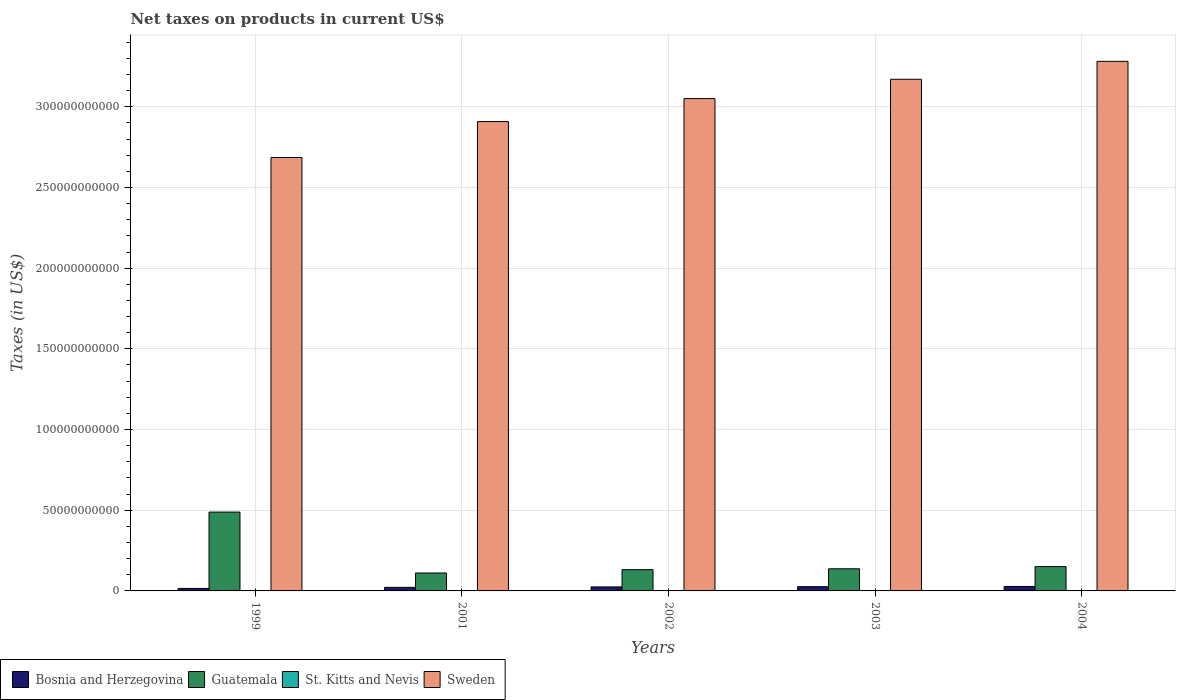How many groups of bars are there?
Your response must be concise. 5. What is the net taxes on products in Sweden in 2002?
Give a very brief answer. 3.05e+11. Across all years, what is the maximum net taxes on products in Guatemala?
Your answer should be compact. 4.89e+1. Across all years, what is the minimum net taxes on products in Bosnia and Herzegovina?
Make the answer very short. 1.54e+09. In which year was the net taxes on products in Sweden maximum?
Your answer should be very brief. 2004. In which year was the net taxes on products in St. Kitts and Nevis minimum?
Your answer should be compact. 2001. What is the total net taxes on products in Sweden in the graph?
Make the answer very short. 1.51e+12. What is the difference between the net taxes on products in Bosnia and Herzegovina in 2001 and that in 2002?
Make the answer very short. -2.75e+08. What is the difference between the net taxes on products in Bosnia and Herzegovina in 2001 and the net taxes on products in Sweden in 1999?
Make the answer very short. -2.66e+11. What is the average net taxes on products in Bosnia and Herzegovina per year?
Make the answer very short. 2.33e+09. In the year 2001, what is the difference between the net taxes on products in St. Kitts and Nevis and net taxes on products in Guatemala?
Give a very brief answer. -1.10e+1. In how many years, is the net taxes on products in Sweden greater than 260000000000 US$?
Offer a terse response. 5. What is the ratio of the net taxes on products in St. Kitts and Nevis in 2003 to that in 2004?
Keep it short and to the point. 0.88. What is the difference between the highest and the second highest net taxes on products in Guatemala?
Provide a succinct answer. 3.38e+1. What is the difference between the highest and the lowest net taxes on products in Sweden?
Offer a terse response. 5.96e+1. In how many years, is the net taxes on products in Sweden greater than the average net taxes on products in Sweden taken over all years?
Make the answer very short. 3. Is the sum of the net taxes on products in Bosnia and Herzegovina in 1999 and 2002 greater than the maximum net taxes on products in St. Kitts and Nevis across all years?
Your response must be concise. Yes. What does the 3rd bar from the left in 2001 represents?
Provide a short and direct response. St. Kitts and Nevis. How many bars are there?
Give a very brief answer. 20. Are all the bars in the graph horizontal?
Your answer should be very brief. No. How many years are there in the graph?
Offer a very short reply. 5. What is the difference between two consecutive major ticks on the Y-axis?
Keep it short and to the point. 5.00e+1. Does the graph contain any zero values?
Offer a terse response. No. Where does the legend appear in the graph?
Provide a short and direct response. Bottom left. How many legend labels are there?
Keep it short and to the point. 4. How are the legend labels stacked?
Ensure brevity in your answer.  Horizontal. What is the title of the graph?
Your response must be concise. Net taxes on products in current US$. Does "Norway" appear as one of the legend labels in the graph?
Provide a succinct answer. No. What is the label or title of the X-axis?
Ensure brevity in your answer.  Years. What is the label or title of the Y-axis?
Keep it short and to the point. Taxes (in US$). What is the Taxes (in US$) in Bosnia and Herzegovina in 1999?
Offer a terse response. 1.54e+09. What is the Taxes (in US$) of Guatemala in 1999?
Your answer should be compact. 4.89e+1. What is the Taxes (in US$) in St. Kitts and Nevis in 1999?
Your answer should be compact. 1.29e+08. What is the Taxes (in US$) in Sweden in 1999?
Your answer should be compact. 2.69e+11. What is the Taxes (in US$) of Bosnia and Herzegovina in 2001?
Offer a very short reply. 2.21e+09. What is the Taxes (in US$) in Guatemala in 2001?
Your response must be concise. 1.11e+1. What is the Taxes (in US$) of St. Kitts and Nevis in 2001?
Give a very brief answer. 1.27e+08. What is the Taxes (in US$) of Sweden in 2001?
Your response must be concise. 2.91e+11. What is the Taxes (in US$) of Bosnia and Herzegovina in 2002?
Make the answer very short. 2.49e+09. What is the Taxes (in US$) in Guatemala in 2002?
Your answer should be very brief. 1.32e+1. What is the Taxes (in US$) in St. Kitts and Nevis in 2002?
Provide a short and direct response. 1.40e+08. What is the Taxes (in US$) of Sweden in 2002?
Your answer should be compact. 3.05e+11. What is the Taxes (in US$) in Bosnia and Herzegovina in 2003?
Ensure brevity in your answer.  2.63e+09. What is the Taxes (in US$) in Guatemala in 2003?
Offer a terse response. 1.37e+1. What is the Taxes (in US$) in St. Kitts and Nevis in 2003?
Keep it short and to the point. 1.56e+08. What is the Taxes (in US$) in Sweden in 2003?
Make the answer very short. 3.17e+11. What is the Taxes (in US$) of Bosnia and Herzegovina in 2004?
Make the answer very short. 2.77e+09. What is the Taxes (in US$) of Guatemala in 2004?
Provide a short and direct response. 1.51e+1. What is the Taxes (in US$) in St. Kitts and Nevis in 2004?
Keep it short and to the point. 1.77e+08. What is the Taxes (in US$) of Sweden in 2004?
Give a very brief answer. 3.28e+11. Across all years, what is the maximum Taxes (in US$) in Bosnia and Herzegovina?
Your answer should be very brief. 2.77e+09. Across all years, what is the maximum Taxes (in US$) of Guatemala?
Your answer should be very brief. 4.89e+1. Across all years, what is the maximum Taxes (in US$) in St. Kitts and Nevis?
Your answer should be compact. 1.77e+08. Across all years, what is the maximum Taxes (in US$) in Sweden?
Your answer should be very brief. 3.28e+11. Across all years, what is the minimum Taxes (in US$) in Bosnia and Herzegovina?
Offer a terse response. 1.54e+09. Across all years, what is the minimum Taxes (in US$) of Guatemala?
Your response must be concise. 1.11e+1. Across all years, what is the minimum Taxes (in US$) in St. Kitts and Nevis?
Offer a very short reply. 1.27e+08. Across all years, what is the minimum Taxes (in US$) in Sweden?
Your response must be concise. 2.69e+11. What is the total Taxes (in US$) of Bosnia and Herzegovina in the graph?
Your answer should be very brief. 1.16e+1. What is the total Taxes (in US$) in Guatemala in the graph?
Provide a succinct answer. 1.02e+11. What is the total Taxes (in US$) of St. Kitts and Nevis in the graph?
Give a very brief answer. 7.28e+08. What is the total Taxes (in US$) of Sweden in the graph?
Your answer should be very brief. 1.51e+12. What is the difference between the Taxes (in US$) in Bosnia and Herzegovina in 1999 and that in 2001?
Your response must be concise. -6.72e+08. What is the difference between the Taxes (in US$) in Guatemala in 1999 and that in 2001?
Give a very brief answer. 3.77e+1. What is the difference between the Taxes (in US$) of St. Kitts and Nevis in 1999 and that in 2001?
Make the answer very short. 2.08e+06. What is the difference between the Taxes (in US$) in Sweden in 1999 and that in 2001?
Ensure brevity in your answer.  -2.22e+1. What is the difference between the Taxes (in US$) in Bosnia and Herzegovina in 1999 and that in 2002?
Provide a succinct answer. -9.47e+08. What is the difference between the Taxes (in US$) in Guatemala in 1999 and that in 2002?
Ensure brevity in your answer.  3.57e+1. What is the difference between the Taxes (in US$) of St. Kitts and Nevis in 1999 and that in 2002?
Your answer should be very brief. -1.12e+07. What is the difference between the Taxes (in US$) in Sweden in 1999 and that in 2002?
Your response must be concise. -3.65e+1. What is the difference between the Taxes (in US$) in Bosnia and Herzegovina in 1999 and that in 2003?
Keep it short and to the point. -1.09e+09. What is the difference between the Taxes (in US$) of Guatemala in 1999 and that in 2003?
Provide a succinct answer. 3.51e+1. What is the difference between the Taxes (in US$) of St. Kitts and Nevis in 1999 and that in 2003?
Keep it short and to the point. -2.71e+07. What is the difference between the Taxes (in US$) in Sweden in 1999 and that in 2003?
Your answer should be very brief. -4.85e+1. What is the difference between the Taxes (in US$) in Bosnia and Herzegovina in 1999 and that in 2004?
Offer a very short reply. -1.23e+09. What is the difference between the Taxes (in US$) of Guatemala in 1999 and that in 2004?
Make the answer very short. 3.38e+1. What is the difference between the Taxes (in US$) of St. Kitts and Nevis in 1999 and that in 2004?
Your answer should be very brief. -4.76e+07. What is the difference between the Taxes (in US$) in Sweden in 1999 and that in 2004?
Keep it short and to the point. -5.96e+1. What is the difference between the Taxes (in US$) of Bosnia and Herzegovina in 2001 and that in 2002?
Offer a very short reply. -2.75e+08. What is the difference between the Taxes (in US$) in Guatemala in 2001 and that in 2002?
Make the answer very short. -2.08e+09. What is the difference between the Taxes (in US$) in St. Kitts and Nevis in 2001 and that in 2002?
Offer a very short reply. -1.33e+07. What is the difference between the Taxes (in US$) of Sweden in 2001 and that in 2002?
Keep it short and to the point. -1.42e+1. What is the difference between the Taxes (in US$) in Bosnia and Herzegovina in 2001 and that in 2003?
Make the answer very short. -4.14e+08. What is the difference between the Taxes (in US$) of Guatemala in 2001 and that in 2003?
Give a very brief answer. -2.61e+09. What is the difference between the Taxes (in US$) of St. Kitts and Nevis in 2001 and that in 2003?
Keep it short and to the point. -2.92e+07. What is the difference between the Taxes (in US$) in Sweden in 2001 and that in 2003?
Offer a terse response. -2.62e+1. What is the difference between the Taxes (in US$) in Bosnia and Herzegovina in 2001 and that in 2004?
Your answer should be compact. -5.57e+08. What is the difference between the Taxes (in US$) in Guatemala in 2001 and that in 2004?
Provide a short and direct response. -3.95e+09. What is the difference between the Taxes (in US$) of St. Kitts and Nevis in 2001 and that in 2004?
Offer a very short reply. -4.97e+07. What is the difference between the Taxes (in US$) of Sweden in 2001 and that in 2004?
Make the answer very short. -3.73e+1. What is the difference between the Taxes (in US$) of Bosnia and Herzegovina in 2002 and that in 2003?
Give a very brief answer. -1.39e+08. What is the difference between the Taxes (in US$) of Guatemala in 2002 and that in 2003?
Keep it short and to the point. -5.32e+08. What is the difference between the Taxes (in US$) of St. Kitts and Nevis in 2002 and that in 2003?
Give a very brief answer. -1.59e+07. What is the difference between the Taxes (in US$) in Sweden in 2002 and that in 2003?
Provide a short and direct response. -1.20e+1. What is the difference between the Taxes (in US$) in Bosnia and Herzegovina in 2002 and that in 2004?
Offer a terse response. -2.81e+08. What is the difference between the Taxes (in US$) in Guatemala in 2002 and that in 2004?
Provide a succinct answer. -1.87e+09. What is the difference between the Taxes (in US$) in St. Kitts and Nevis in 2002 and that in 2004?
Keep it short and to the point. -3.64e+07. What is the difference between the Taxes (in US$) in Sweden in 2002 and that in 2004?
Your response must be concise. -2.31e+1. What is the difference between the Taxes (in US$) of Bosnia and Herzegovina in 2003 and that in 2004?
Give a very brief answer. -1.42e+08. What is the difference between the Taxes (in US$) of Guatemala in 2003 and that in 2004?
Make the answer very short. -1.34e+09. What is the difference between the Taxes (in US$) of St. Kitts and Nevis in 2003 and that in 2004?
Your response must be concise. -2.05e+07. What is the difference between the Taxes (in US$) in Sweden in 2003 and that in 2004?
Keep it short and to the point. -1.11e+1. What is the difference between the Taxes (in US$) in Bosnia and Herzegovina in 1999 and the Taxes (in US$) in Guatemala in 2001?
Ensure brevity in your answer.  -9.57e+09. What is the difference between the Taxes (in US$) in Bosnia and Herzegovina in 1999 and the Taxes (in US$) in St. Kitts and Nevis in 2001?
Ensure brevity in your answer.  1.41e+09. What is the difference between the Taxes (in US$) in Bosnia and Herzegovina in 1999 and the Taxes (in US$) in Sweden in 2001?
Your response must be concise. -2.89e+11. What is the difference between the Taxes (in US$) of Guatemala in 1999 and the Taxes (in US$) of St. Kitts and Nevis in 2001?
Make the answer very short. 4.87e+1. What is the difference between the Taxes (in US$) of Guatemala in 1999 and the Taxes (in US$) of Sweden in 2001?
Provide a short and direct response. -2.42e+11. What is the difference between the Taxes (in US$) of St. Kitts and Nevis in 1999 and the Taxes (in US$) of Sweden in 2001?
Provide a short and direct response. -2.91e+11. What is the difference between the Taxes (in US$) in Bosnia and Herzegovina in 1999 and the Taxes (in US$) in Guatemala in 2002?
Your response must be concise. -1.16e+1. What is the difference between the Taxes (in US$) in Bosnia and Herzegovina in 1999 and the Taxes (in US$) in St. Kitts and Nevis in 2002?
Offer a very short reply. 1.40e+09. What is the difference between the Taxes (in US$) in Bosnia and Herzegovina in 1999 and the Taxes (in US$) in Sweden in 2002?
Your answer should be compact. -3.04e+11. What is the difference between the Taxes (in US$) of Guatemala in 1999 and the Taxes (in US$) of St. Kitts and Nevis in 2002?
Offer a terse response. 4.87e+1. What is the difference between the Taxes (in US$) of Guatemala in 1999 and the Taxes (in US$) of Sweden in 2002?
Provide a succinct answer. -2.56e+11. What is the difference between the Taxes (in US$) in St. Kitts and Nevis in 1999 and the Taxes (in US$) in Sweden in 2002?
Your answer should be very brief. -3.05e+11. What is the difference between the Taxes (in US$) in Bosnia and Herzegovina in 1999 and the Taxes (in US$) in Guatemala in 2003?
Ensure brevity in your answer.  -1.22e+1. What is the difference between the Taxes (in US$) in Bosnia and Herzegovina in 1999 and the Taxes (in US$) in St. Kitts and Nevis in 2003?
Your response must be concise. 1.38e+09. What is the difference between the Taxes (in US$) of Bosnia and Herzegovina in 1999 and the Taxes (in US$) of Sweden in 2003?
Your answer should be compact. -3.16e+11. What is the difference between the Taxes (in US$) in Guatemala in 1999 and the Taxes (in US$) in St. Kitts and Nevis in 2003?
Give a very brief answer. 4.87e+1. What is the difference between the Taxes (in US$) of Guatemala in 1999 and the Taxes (in US$) of Sweden in 2003?
Your response must be concise. -2.68e+11. What is the difference between the Taxes (in US$) of St. Kitts and Nevis in 1999 and the Taxes (in US$) of Sweden in 2003?
Ensure brevity in your answer.  -3.17e+11. What is the difference between the Taxes (in US$) of Bosnia and Herzegovina in 1999 and the Taxes (in US$) of Guatemala in 2004?
Your answer should be very brief. -1.35e+1. What is the difference between the Taxes (in US$) of Bosnia and Herzegovina in 1999 and the Taxes (in US$) of St. Kitts and Nevis in 2004?
Your response must be concise. 1.36e+09. What is the difference between the Taxes (in US$) in Bosnia and Herzegovina in 1999 and the Taxes (in US$) in Sweden in 2004?
Your answer should be very brief. -3.27e+11. What is the difference between the Taxes (in US$) in Guatemala in 1999 and the Taxes (in US$) in St. Kitts and Nevis in 2004?
Provide a short and direct response. 4.87e+1. What is the difference between the Taxes (in US$) in Guatemala in 1999 and the Taxes (in US$) in Sweden in 2004?
Give a very brief answer. -2.79e+11. What is the difference between the Taxes (in US$) in St. Kitts and Nevis in 1999 and the Taxes (in US$) in Sweden in 2004?
Offer a very short reply. -3.28e+11. What is the difference between the Taxes (in US$) of Bosnia and Herzegovina in 2001 and the Taxes (in US$) of Guatemala in 2002?
Ensure brevity in your answer.  -1.10e+1. What is the difference between the Taxes (in US$) of Bosnia and Herzegovina in 2001 and the Taxes (in US$) of St. Kitts and Nevis in 2002?
Give a very brief answer. 2.07e+09. What is the difference between the Taxes (in US$) of Bosnia and Herzegovina in 2001 and the Taxes (in US$) of Sweden in 2002?
Make the answer very short. -3.03e+11. What is the difference between the Taxes (in US$) in Guatemala in 2001 and the Taxes (in US$) in St. Kitts and Nevis in 2002?
Your response must be concise. 1.10e+1. What is the difference between the Taxes (in US$) in Guatemala in 2001 and the Taxes (in US$) in Sweden in 2002?
Provide a short and direct response. -2.94e+11. What is the difference between the Taxes (in US$) of St. Kitts and Nevis in 2001 and the Taxes (in US$) of Sweden in 2002?
Offer a terse response. -3.05e+11. What is the difference between the Taxes (in US$) of Bosnia and Herzegovina in 2001 and the Taxes (in US$) of Guatemala in 2003?
Your answer should be compact. -1.15e+1. What is the difference between the Taxes (in US$) of Bosnia and Herzegovina in 2001 and the Taxes (in US$) of St. Kitts and Nevis in 2003?
Make the answer very short. 2.05e+09. What is the difference between the Taxes (in US$) in Bosnia and Herzegovina in 2001 and the Taxes (in US$) in Sweden in 2003?
Your answer should be very brief. -3.15e+11. What is the difference between the Taxes (in US$) in Guatemala in 2001 and the Taxes (in US$) in St. Kitts and Nevis in 2003?
Your response must be concise. 1.10e+1. What is the difference between the Taxes (in US$) in Guatemala in 2001 and the Taxes (in US$) in Sweden in 2003?
Offer a very short reply. -3.06e+11. What is the difference between the Taxes (in US$) in St. Kitts and Nevis in 2001 and the Taxes (in US$) in Sweden in 2003?
Offer a terse response. -3.17e+11. What is the difference between the Taxes (in US$) of Bosnia and Herzegovina in 2001 and the Taxes (in US$) of Guatemala in 2004?
Provide a succinct answer. -1.28e+1. What is the difference between the Taxes (in US$) in Bosnia and Herzegovina in 2001 and the Taxes (in US$) in St. Kitts and Nevis in 2004?
Your answer should be very brief. 2.03e+09. What is the difference between the Taxes (in US$) in Bosnia and Herzegovina in 2001 and the Taxes (in US$) in Sweden in 2004?
Your answer should be compact. -3.26e+11. What is the difference between the Taxes (in US$) in Guatemala in 2001 and the Taxes (in US$) in St. Kitts and Nevis in 2004?
Make the answer very short. 1.09e+1. What is the difference between the Taxes (in US$) in Guatemala in 2001 and the Taxes (in US$) in Sweden in 2004?
Make the answer very short. -3.17e+11. What is the difference between the Taxes (in US$) of St. Kitts and Nevis in 2001 and the Taxes (in US$) of Sweden in 2004?
Your answer should be compact. -3.28e+11. What is the difference between the Taxes (in US$) of Bosnia and Herzegovina in 2002 and the Taxes (in US$) of Guatemala in 2003?
Offer a terse response. -1.12e+1. What is the difference between the Taxes (in US$) in Bosnia and Herzegovina in 2002 and the Taxes (in US$) in St. Kitts and Nevis in 2003?
Offer a very short reply. 2.33e+09. What is the difference between the Taxes (in US$) of Bosnia and Herzegovina in 2002 and the Taxes (in US$) of Sweden in 2003?
Ensure brevity in your answer.  -3.15e+11. What is the difference between the Taxes (in US$) in Guatemala in 2002 and the Taxes (in US$) in St. Kitts and Nevis in 2003?
Your answer should be compact. 1.30e+1. What is the difference between the Taxes (in US$) of Guatemala in 2002 and the Taxes (in US$) of Sweden in 2003?
Give a very brief answer. -3.04e+11. What is the difference between the Taxes (in US$) in St. Kitts and Nevis in 2002 and the Taxes (in US$) in Sweden in 2003?
Your answer should be very brief. -3.17e+11. What is the difference between the Taxes (in US$) of Bosnia and Herzegovina in 2002 and the Taxes (in US$) of Guatemala in 2004?
Provide a short and direct response. -1.26e+1. What is the difference between the Taxes (in US$) in Bosnia and Herzegovina in 2002 and the Taxes (in US$) in St. Kitts and Nevis in 2004?
Offer a terse response. 2.31e+09. What is the difference between the Taxes (in US$) in Bosnia and Herzegovina in 2002 and the Taxes (in US$) in Sweden in 2004?
Make the answer very short. -3.26e+11. What is the difference between the Taxes (in US$) in Guatemala in 2002 and the Taxes (in US$) in St. Kitts and Nevis in 2004?
Keep it short and to the point. 1.30e+1. What is the difference between the Taxes (in US$) in Guatemala in 2002 and the Taxes (in US$) in Sweden in 2004?
Provide a short and direct response. -3.15e+11. What is the difference between the Taxes (in US$) of St. Kitts and Nevis in 2002 and the Taxes (in US$) of Sweden in 2004?
Give a very brief answer. -3.28e+11. What is the difference between the Taxes (in US$) in Bosnia and Herzegovina in 2003 and the Taxes (in US$) in Guatemala in 2004?
Keep it short and to the point. -1.24e+1. What is the difference between the Taxes (in US$) of Bosnia and Herzegovina in 2003 and the Taxes (in US$) of St. Kitts and Nevis in 2004?
Ensure brevity in your answer.  2.45e+09. What is the difference between the Taxes (in US$) of Bosnia and Herzegovina in 2003 and the Taxes (in US$) of Sweden in 2004?
Your response must be concise. -3.26e+11. What is the difference between the Taxes (in US$) of Guatemala in 2003 and the Taxes (in US$) of St. Kitts and Nevis in 2004?
Give a very brief answer. 1.35e+1. What is the difference between the Taxes (in US$) in Guatemala in 2003 and the Taxes (in US$) in Sweden in 2004?
Offer a terse response. -3.14e+11. What is the difference between the Taxes (in US$) of St. Kitts and Nevis in 2003 and the Taxes (in US$) of Sweden in 2004?
Offer a very short reply. -3.28e+11. What is the average Taxes (in US$) of Bosnia and Herzegovina per year?
Offer a very short reply. 2.33e+09. What is the average Taxes (in US$) of Guatemala per year?
Ensure brevity in your answer.  2.04e+1. What is the average Taxes (in US$) in St. Kitts and Nevis per year?
Give a very brief answer. 1.46e+08. What is the average Taxes (in US$) of Sweden per year?
Provide a succinct answer. 3.02e+11. In the year 1999, what is the difference between the Taxes (in US$) in Bosnia and Herzegovina and Taxes (in US$) in Guatemala?
Give a very brief answer. -4.73e+1. In the year 1999, what is the difference between the Taxes (in US$) of Bosnia and Herzegovina and Taxes (in US$) of St. Kitts and Nevis?
Give a very brief answer. 1.41e+09. In the year 1999, what is the difference between the Taxes (in US$) of Bosnia and Herzegovina and Taxes (in US$) of Sweden?
Your answer should be very brief. -2.67e+11. In the year 1999, what is the difference between the Taxes (in US$) of Guatemala and Taxes (in US$) of St. Kitts and Nevis?
Ensure brevity in your answer.  4.87e+1. In the year 1999, what is the difference between the Taxes (in US$) in Guatemala and Taxes (in US$) in Sweden?
Provide a succinct answer. -2.20e+11. In the year 1999, what is the difference between the Taxes (in US$) in St. Kitts and Nevis and Taxes (in US$) in Sweden?
Provide a short and direct response. -2.68e+11. In the year 2001, what is the difference between the Taxes (in US$) of Bosnia and Herzegovina and Taxes (in US$) of Guatemala?
Provide a succinct answer. -8.90e+09. In the year 2001, what is the difference between the Taxes (in US$) in Bosnia and Herzegovina and Taxes (in US$) in St. Kitts and Nevis?
Offer a terse response. 2.08e+09. In the year 2001, what is the difference between the Taxes (in US$) of Bosnia and Herzegovina and Taxes (in US$) of Sweden?
Offer a very short reply. -2.89e+11. In the year 2001, what is the difference between the Taxes (in US$) in Guatemala and Taxes (in US$) in St. Kitts and Nevis?
Provide a succinct answer. 1.10e+1. In the year 2001, what is the difference between the Taxes (in US$) in Guatemala and Taxes (in US$) in Sweden?
Keep it short and to the point. -2.80e+11. In the year 2001, what is the difference between the Taxes (in US$) of St. Kitts and Nevis and Taxes (in US$) of Sweden?
Offer a very short reply. -2.91e+11. In the year 2002, what is the difference between the Taxes (in US$) of Bosnia and Herzegovina and Taxes (in US$) of Guatemala?
Your response must be concise. -1.07e+1. In the year 2002, what is the difference between the Taxes (in US$) in Bosnia and Herzegovina and Taxes (in US$) in St. Kitts and Nevis?
Your answer should be compact. 2.35e+09. In the year 2002, what is the difference between the Taxes (in US$) of Bosnia and Herzegovina and Taxes (in US$) of Sweden?
Your response must be concise. -3.03e+11. In the year 2002, what is the difference between the Taxes (in US$) in Guatemala and Taxes (in US$) in St. Kitts and Nevis?
Offer a very short reply. 1.30e+1. In the year 2002, what is the difference between the Taxes (in US$) of Guatemala and Taxes (in US$) of Sweden?
Your answer should be compact. -2.92e+11. In the year 2002, what is the difference between the Taxes (in US$) in St. Kitts and Nevis and Taxes (in US$) in Sweden?
Provide a succinct answer. -3.05e+11. In the year 2003, what is the difference between the Taxes (in US$) in Bosnia and Herzegovina and Taxes (in US$) in Guatemala?
Your response must be concise. -1.11e+1. In the year 2003, what is the difference between the Taxes (in US$) in Bosnia and Herzegovina and Taxes (in US$) in St. Kitts and Nevis?
Your answer should be compact. 2.47e+09. In the year 2003, what is the difference between the Taxes (in US$) in Bosnia and Herzegovina and Taxes (in US$) in Sweden?
Give a very brief answer. -3.14e+11. In the year 2003, what is the difference between the Taxes (in US$) in Guatemala and Taxes (in US$) in St. Kitts and Nevis?
Provide a succinct answer. 1.36e+1. In the year 2003, what is the difference between the Taxes (in US$) of Guatemala and Taxes (in US$) of Sweden?
Your answer should be compact. -3.03e+11. In the year 2003, what is the difference between the Taxes (in US$) in St. Kitts and Nevis and Taxes (in US$) in Sweden?
Keep it short and to the point. -3.17e+11. In the year 2004, what is the difference between the Taxes (in US$) of Bosnia and Herzegovina and Taxes (in US$) of Guatemala?
Your response must be concise. -1.23e+1. In the year 2004, what is the difference between the Taxes (in US$) of Bosnia and Herzegovina and Taxes (in US$) of St. Kitts and Nevis?
Give a very brief answer. 2.59e+09. In the year 2004, what is the difference between the Taxes (in US$) of Bosnia and Herzegovina and Taxes (in US$) of Sweden?
Your answer should be compact. -3.25e+11. In the year 2004, what is the difference between the Taxes (in US$) of Guatemala and Taxes (in US$) of St. Kitts and Nevis?
Give a very brief answer. 1.49e+1. In the year 2004, what is the difference between the Taxes (in US$) in Guatemala and Taxes (in US$) in Sweden?
Provide a short and direct response. -3.13e+11. In the year 2004, what is the difference between the Taxes (in US$) of St. Kitts and Nevis and Taxes (in US$) of Sweden?
Your answer should be very brief. -3.28e+11. What is the ratio of the Taxes (in US$) of Bosnia and Herzegovina in 1999 to that in 2001?
Make the answer very short. 0.7. What is the ratio of the Taxes (in US$) in Guatemala in 1999 to that in 2001?
Keep it short and to the point. 4.4. What is the ratio of the Taxes (in US$) in St. Kitts and Nevis in 1999 to that in 2001?
Ensure brevity in your answer.  1.02. What is the ratio of the Taxes (in US$) of Sweden in 1999 to that in 2001?
Offer a terse response. 0.92. What is the ratio of the Taxes (in US$) in Bosnia and Herzegovina in 1999 to that in 2002?
Your answer should be compact. 0.62. What is the ratio of the Taxes (in US$) in Guatemala in 1999 to that in 2002?
Your response must be concise. 3.71. What is the ratio of the Taxes (in US$) in St. Kitts and Nevis in 1999 to that in 2002?
Your answer should be very brief. 0.92. What is the ratio of the Taxes (in US$) of Sweden in 1999 to that in 2002?
Your response must be concise. 0.88. What is the ratio of the Taxes (in US$) of Bosnia and Herzegovina in 1999 to that in 2003?
Your answer should be very brief. 0.59. What is the ratio of the Taxes (in US$) of Guatemala in 1999 to that in 2003?
Give a very brief answer. 3.56. What is the ratio of the Taxes (in US$) in St. Kitts and Nevis in 1999 to that in 2003?
Ensure brevity in your answer.  0.83. What is the ratio of the Taxes (in US$) of Sweden in 1999 to that in 2003?
Give a very brief answer. 0.85. What is the ratio of the Taxes (in US$) in Bosnia and Herzegovina in 1999 to that in 2004?
Provide a short and direct response. 0.56. What is the ratio of the Taxes (in US$) in Guatemala in 1999 to that in 2004?
Offer a terse response. 3.24. What is the ratio of the Taxes (in US$) in St. Kitts and Nevis in 1999 to that in 2004?
Your answer should be very brief. 0.73. What is the ratio of the Taxes (in US$) in Sweden in 1999 to that in 2004?
Your answer should be compact. 0.82. What is the ratio of the Taxes (in US$) in Bosnia and Herzegovina in 2001 to that in 2002?
Offer a terse response. 0.89. What is the ratio of the Taxes (in US$) of Guatemala in 2001 to that in 2002?
Your answer should be compact. 0.84. What is the ratio of the Taxes (in US$) in St. Kitts and Nevis in 2001 to that in 2002?
Ensure brevity in your answer.  0.91. What is the ratio of the Taxes (in US$) of Sweden in 2001 to that in 2002?
Ensure brevity in your answer.  0.95. What is the ratio of the Taxes (in US$) in Bosnia and Herzegovina in 2001 to that in 2003?
Offer a very short reply. 0.84. What is the ratio of the Taxes (in US$) in Guatemala in 2001 to that in 2003?
Keep it short and to the point. 0.81. What is the ratio of the Taxes (in US$) in St. Kitts and Nevis in 2001 to that in 2003?
Give a very brief answer. 0.81. What is the ratio of the Taxes (in US$) of Sweden in 2001 to that in 2003?
Provide a succinct answer. 0.92. What is the ratio of the Taxes (in US$) of Bosnia and Herzegovina in 2001 to that in 2004?
Provide a succinct answer. 0.8. What is the ratio of the Taxes (in US$) in Guatemala in 2001 to that in 2004?
Offer a terse response. 0.74. What is the ratio of the Taxes (in US$) of St. Kitts and Nevis in 2001 to that in 2004?
Offer a very short reply. 0.72. What is the ratio of the Taxes (in US$) of Sweden in 2001 to that in 2004?
Provide a short and direct response. 0.89. What is the ratio of the Taxes (in US$) in Bosnia and Herzegovina in 2002 to that in 2003?
Your response must be concise. 0.95. What is the ratio of the Taxes (in US$) of Guatemala in 2002 to that in 2003?
Ensure brevity in your answer.  0.96. What is the ratio of the Taxes (in US$) in St. Kitts and Nevis in 2002 to that in 2003?
Keep it short and to the point. 0.9. What is the ratio of the Taxes (in US$) in Sweden in 2002 to that in 2003?
Ensure brevity in your answer.  0.96. What is the ratio of the Taxes (in US$) of Bosnia and Herzegovina in 2002 to that in 2004?
Provide a short and direct response. 0.9. What is the ratio of the Taxes (in US$) of Guatemala in 2002 to that in 2004?
Offer a terse response. 0.88. What is the ratio of the Taxes (in US$) in St. Kitts and Nevis in 2002 to that in 2004?
Ensure brevity in your answer.  0.79. What is the ratio of the Taxes (in US$) of Sweden in 2002 to that in 2004?
Make the answer very short. 0.93. What is the ratio of the Taxes (in US$) of Bosnia and Herzegovina in 2003 to that in 2004?
Your response must be concise. 0.95. What is the ratio of the Taxes (in US$) of Guatemala in 2003 to that in 2004?
Provide a succinct answer. 0.91. What is the ratio of the Taxes (in US$) in St. Kitts and Nevis in 2003 to that in 2004?
Your answer should be very brief. 0.88. What is the ratio of the Taxes (in US$) of Sweden in 2003 to that in 2004?
Offer a terse response. 0.97. What is the difference between the highest and the second highest Taxes (in US$) of Bosnia and Herzegovina?
Offer a very short reply. 1.42e+08. What is the difference between the highest and the second highest Taxes (in US$) in Guatemala?
Your response must be concise. 3.38e+1. What is the difference between the highest and the second highest Taxes (in US$) in St. Kitts and Nevis?
Give a very brief answer. 2.05e+07. What is the difference between the highest and the second highest Taxes (in US$) in Sweden?
Offer a very short reply. 1.11e+1. What is the difference between the highest and the lowest Taxes (in US$) in Bosnia and Herzegovina?
Give a very brief answer. 1.23e+09. What is the difference between the highest and the lowest Taxes (in US$) in Guatemala?
Your answer should be compact. 3.77e+1. What is the difference between the highest and the lowest Taxes (in US$) in St. Kitts and Nevis?
Your answer should be very brief. 4.97e+07. What is the difference between the highest and the lowest Taxes (in US$) of Sweden?
Make the answer very short. 5.96e+1. 